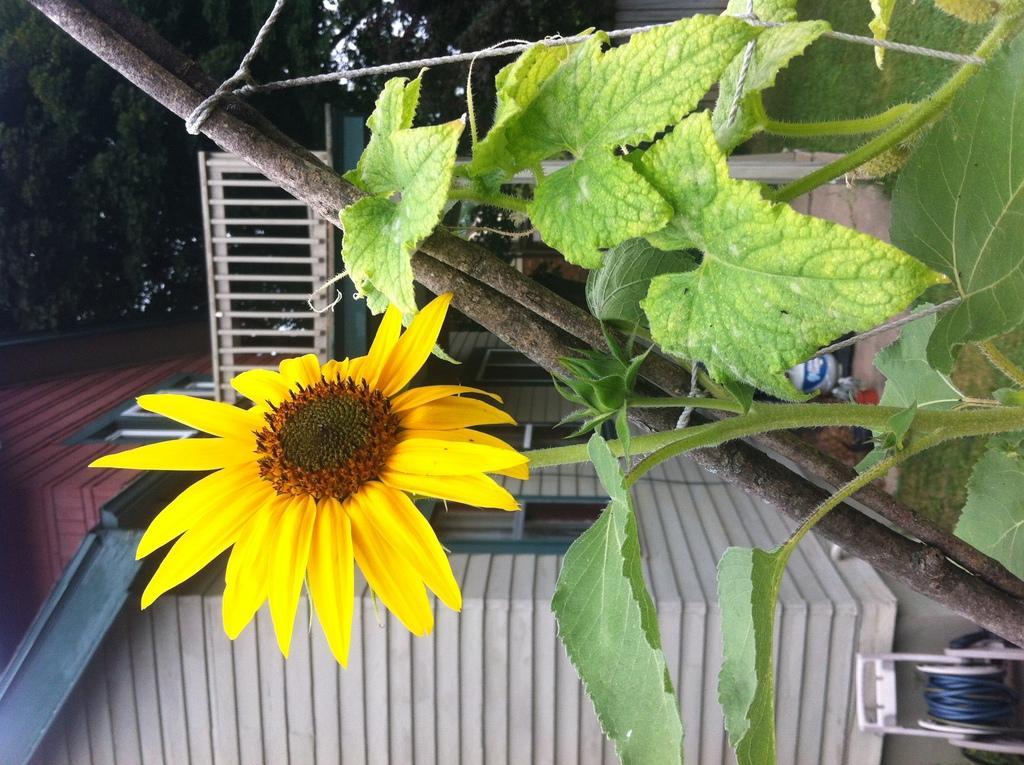Please provide a concise description of this image. In this image we can see plants, building, trees and sky. 